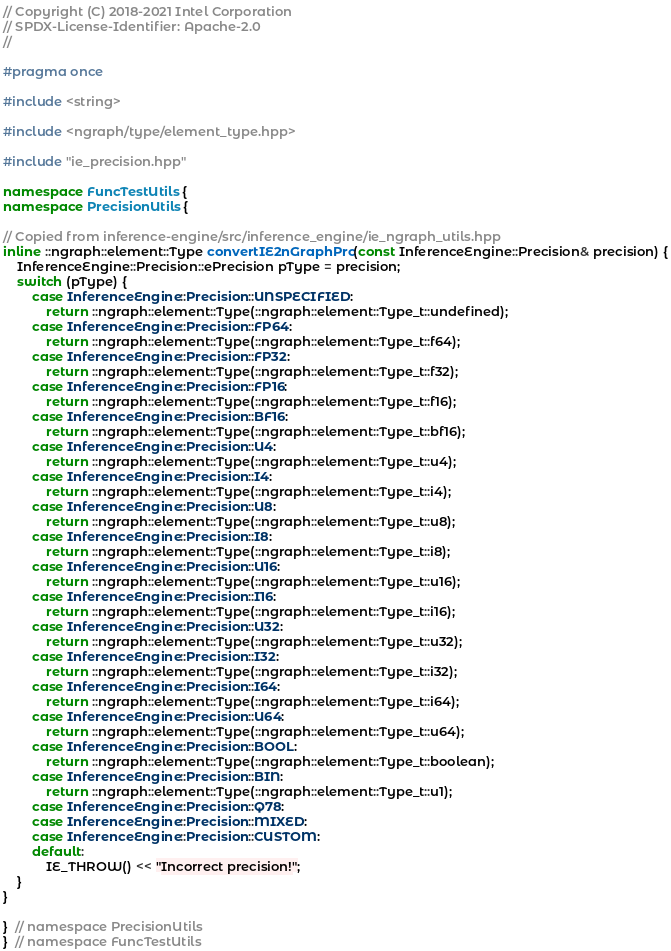Convert code to text. <code><loc_0><loc_0><loc_500><loc_500><_C++_>// Copyright (C) 2018-2021 Intel Corporation
// SPDX-License-Identifier: Apache-2.0
//

#pragma once

#include <string>

#include <ngraph/type/element_type.hpp>

#include "ie_precision.hpp"

namespace FuncTestUtils {
namespace PrecisionUtils {

// Copied from inference-engine/src/inference_engine/ie_ngraph_utils.hpp
inline ::ngraph::element::Type convertIE2nGraphPrc(const InferenceEngine::Precision& precision) {
    InferenceEngine::Precision::ePrecision pType = precision;
    switch (pType) {
        case InferenceEngine::Precision::UNSPECIFIED:
            return ::ngraph::element::Type(::ngraph::element::Type_t::undefined);
        case InferenceEngine::Precision::FP64:
            return ::ngraph::element::Type(::ngraph::element::Type_t::f64);
        case InferenceEngine::Precision::FP32:
            return ::ngraph::element::Type(::ngraph::element::Type_t::f32);
        case InferenceEngine::Precision::FP16:
            return ::ngraph::element::Type(::ngraph::element::Type_t::f16);
        case InferenceEngine::Precision::BF16:
            return ::ngraph::element::Type(::ngraph::element::Type_t::bf16);
        case InferenceEngine::Precision::U4:
            return ::ngraph::element::Type(::ngraph::element::Type_t::u4);
        case InferenceEngine::Precision::I4:
            return ::ngraph::element::Type(::ngraph::element::Type_t::i4);
        case InferenceEngine::Precision::U8:
            return ::ngraph::element::Type(::ngraph::element::Type_t::u8);
        case InferenceEngine::Precision::I8:
            return ::ngraph::element::Type(::ngraph::element::Type_t::i8);
        case InferenceEngine::Precision::U16:
            return ::ngraph::element::Type(::ngraph::element::Type_t::u16);
        case InferenceEngine::Precision::I16:
            return ::ngraph::element::Type(::ngraph::element::Type_t::i16);
        case InferenceEngine::Precision::U32:
            return ::ngraph::element::Type(::ngraph::element::Type_t::u32);
        case InferenceEngine::Precision::I32:
            return ::ngraph::element::Type(::ngraph::element::Type_t::i32);
        case InferenceEngine::Precision::I64:
            return ::ngraph::element::Type(::ngraph::element::Type_t::i64);
        case InferenceEngine::Precision::U64:
            return ::ngraph::element::Type(::ngraph::element::Type_t::u64);
        case InferenceEngine::Precision::BOOL:
            return ::ngraph::element::Type(::ngraph::element::Type_t::boolean);
        case InferenceEngine::Precision::BIN:
            return ::ngraph::element::Type(::ngraph::element::Type_t::u1);
        case InferenceEngine::Precision::Q78:
        case InferenceEngine::Precision::MIXED:
        case InferenceEngine::Precision::CUSTOM:
        default:
            IE_THROW() << "Incorrect precision!";
    }
}

}  // namespace PrecisionUtils
}  // namespace FuncTestUtils
</code> 